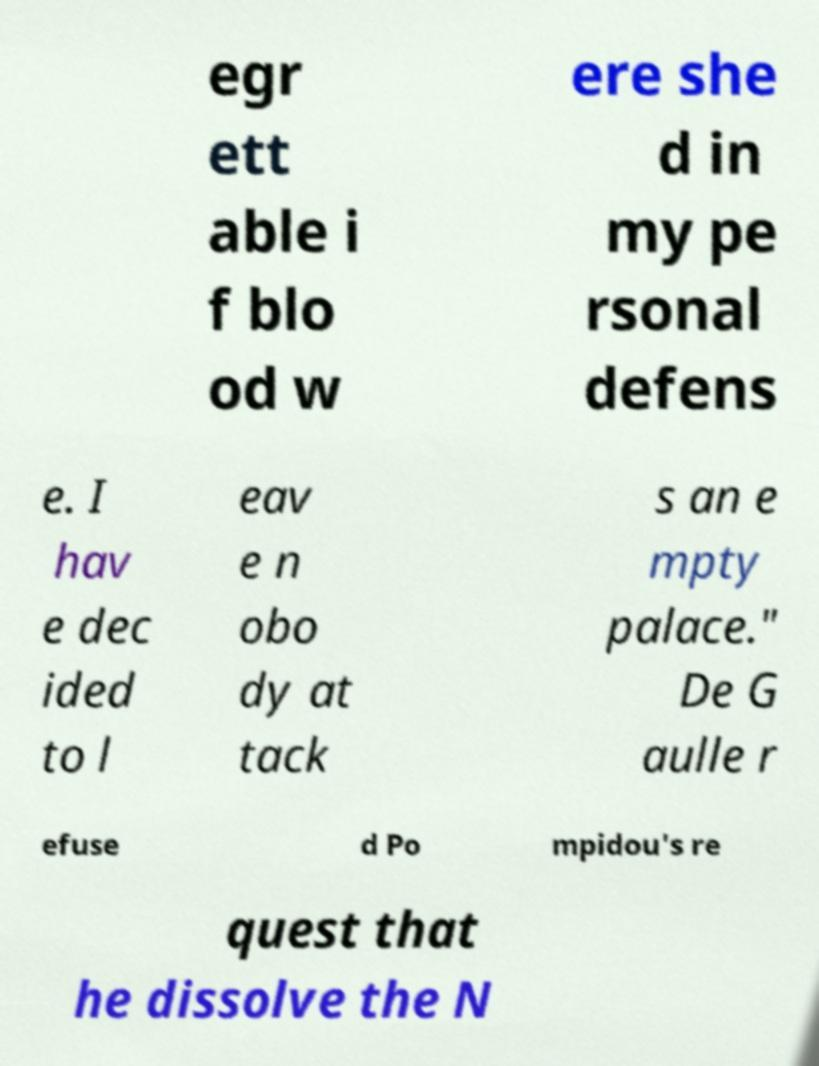Can you accurately transcribe the text from the provided image for me? egr ett able i f blo od w ere she d in my pe rsonal defens e. I hav e dec ided to l eav e n obo dy at tack s an e mpty palace." De G aulle r efuse d Po mpidou's re quest that he dissolve the N 